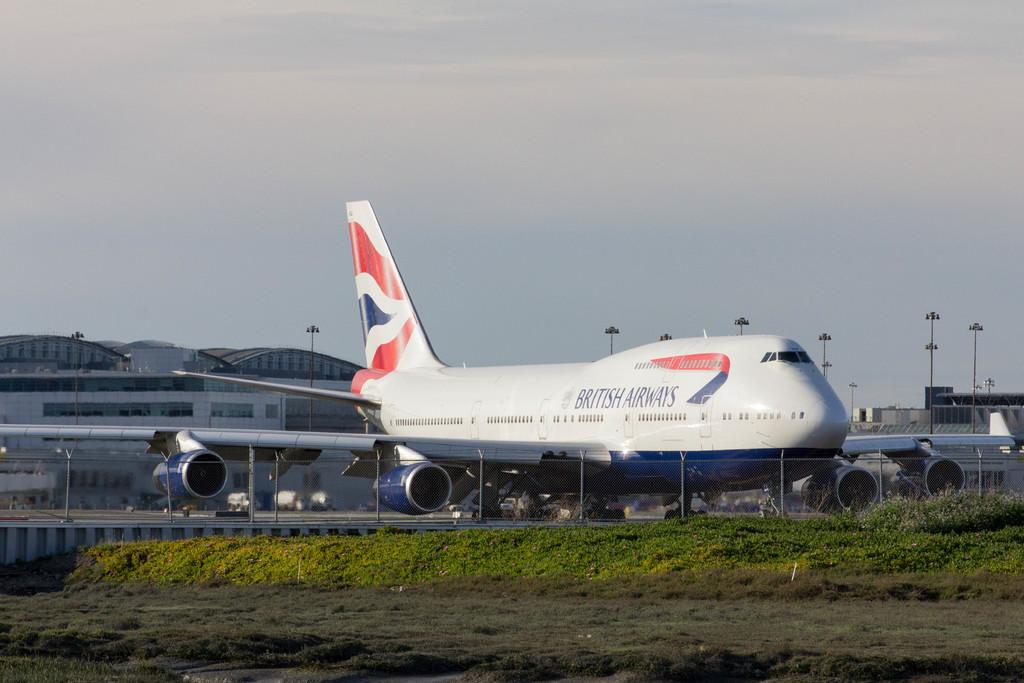<image>
Write a terse but informative summary of the picture. A white a airplane with the word British  on the front. 